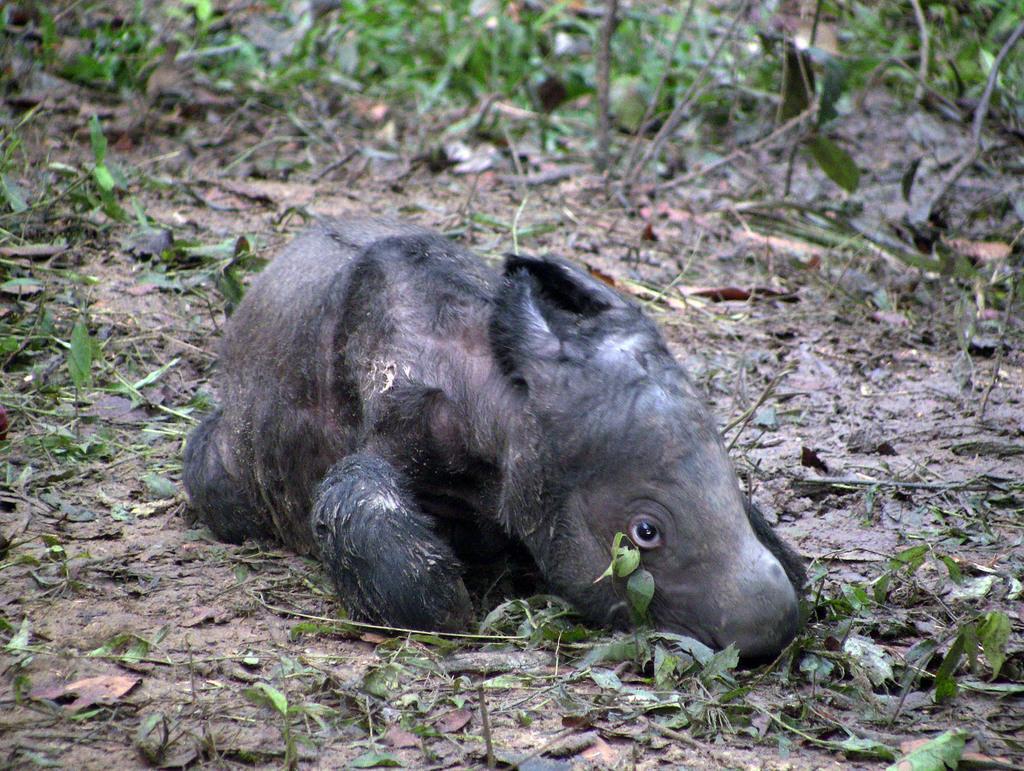Could you give a brief overview of what you see in this image? In this image, we can see an animal on the ground, there are some green color leaves. 